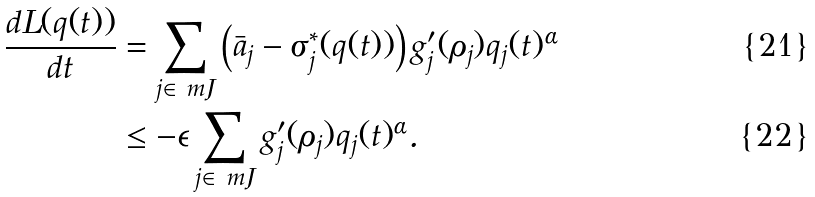<formula> <loc_0><loc_0><loc_500><loc_500>\frac { d L ( q ( t ) ) } { d t } & = \sum _ { j \in \ m J } \left ( \bar { a } _ { j } - { \sigma } _ { j } ^ { * } ( q ( t ) ) \right ) g _ { j } ^ { \prime } ( \rho _ { j } ) q _ { j } ( t ) ^ { \alpha } \\ & \leq - \epsilon \sum _ { j \in \ m J } g _ { j } ^ { \prime } ( \rho _ { j } ) q _ { j } ( t ) ^ { \alpha } .</formula> 